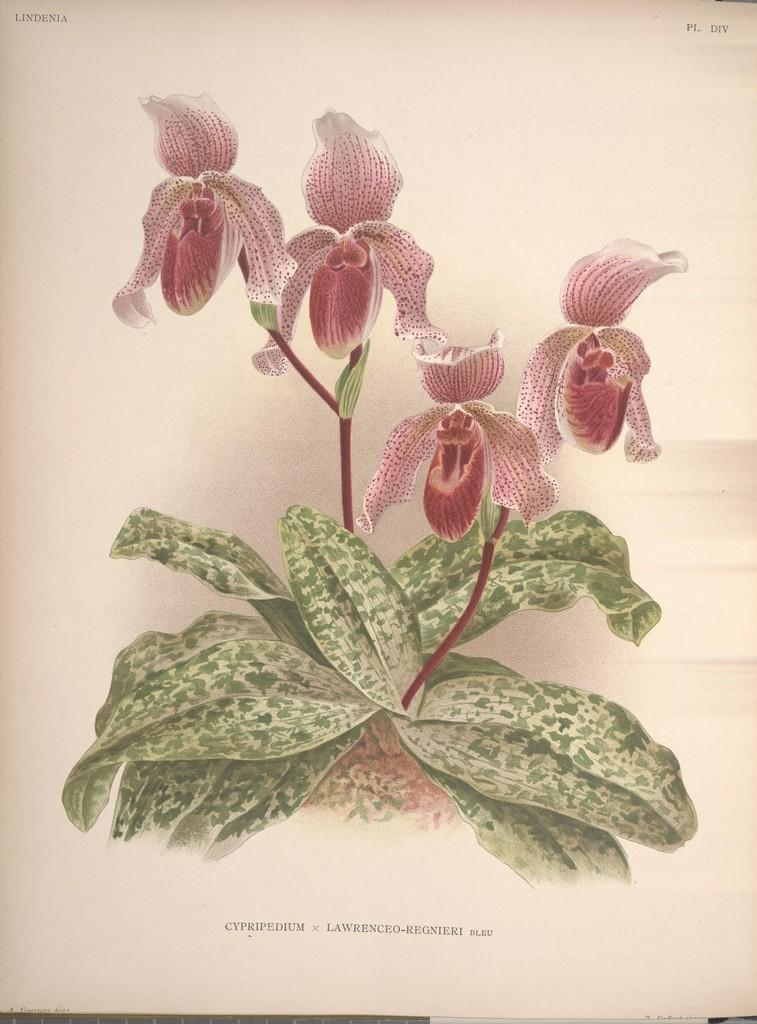What is the main subject in the center of the image? There is a paper in the center of the image. What can be seen on the paper? The paper contains images of plants and flowers. Is there any text on the paper? Yes, there is writing on the paper. How many fairies are flying around the paper in the image? There are no fairies present in the image; it only features a paper with images of plants and flowers and writing. 